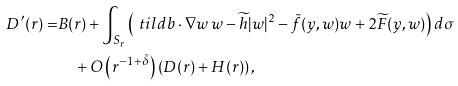<formula> <loc_0><loc_0><loc_500><loc_500>D ^ { \prime } ( r ) = & B ( r ) + \int _ { S _ { r } } \left ( \ t i l d b \cdot \nabla w \, w - \widetilde { h } | w | ^ { 2 } - \tilde { f } ( y , w ) w + 2 \widetilde { F } ( y , w ) \right ) d \sigma \\ & \quad + O \left ( r ^ { - 1 + \tilde { \delta } } \right ) \left ( D ( r ) + H ( r ) \right ) ,</formula> 